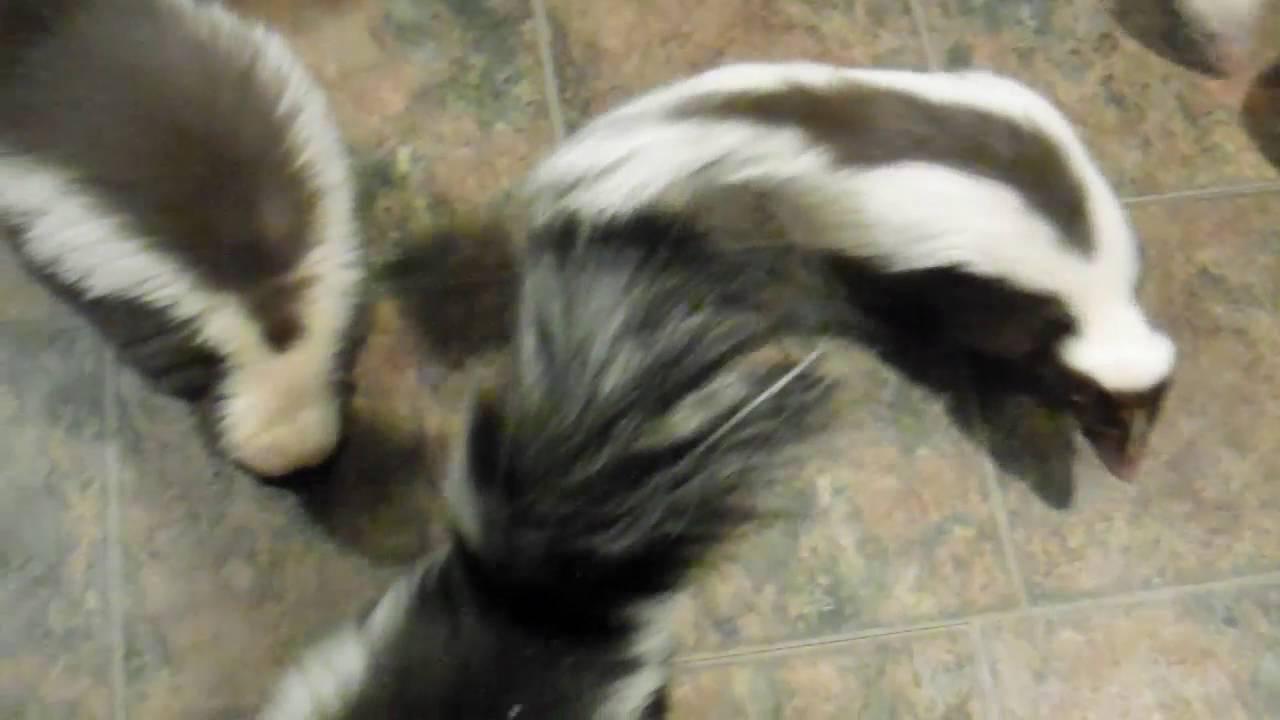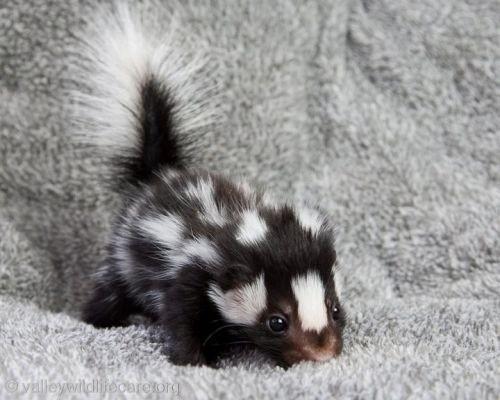The first image is the image on the left, the second image is the image on the right. Considering the images on both sides, is "The right image shows one rightward-facing skunk with an oval food item in front of its nose." valid? Answer yes or no. No. The first image is the image on the left, the second image is the image on the right. For the images displayed, is the sentence "There are only two skunks." factually correct? Answer yes or no. No. 